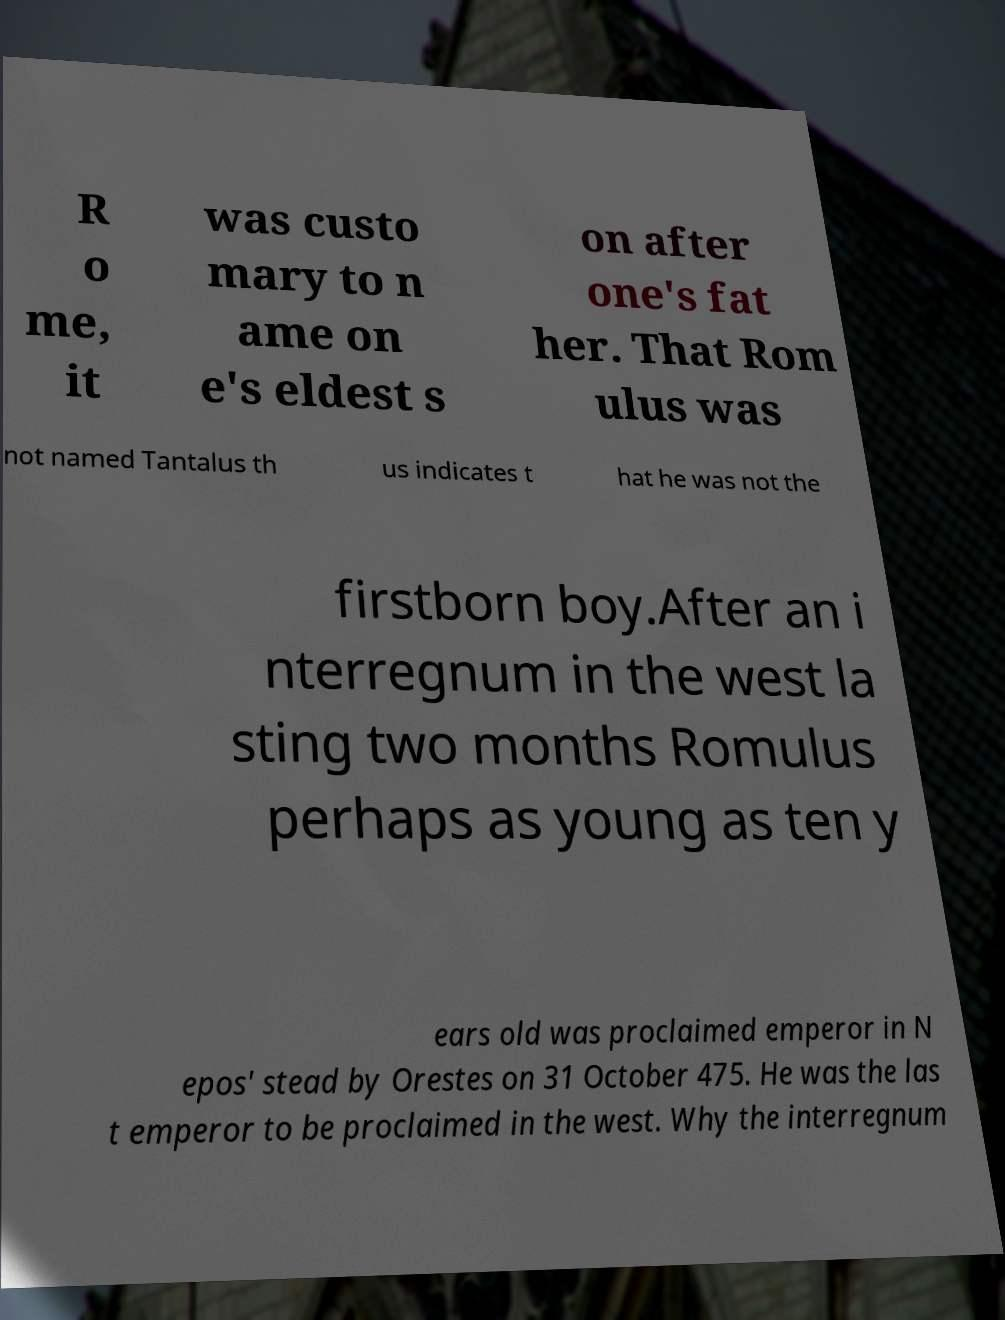Could you assist in decoding the text presented in this image and type it out clearly? R o me, it was custo mary to n ame on e's eldest s on after one's fat her. That Rom ulus was not named Tantalus th us indicates t hat he was not the firstborn boy.After an i nterregnum in the west la sting two months Romulus perhaps as young as ten y ears old was proclaimed emperor in N epos' stead by Orestes on 31 October 475. He was the las t emperor to be proclaimed in the west. Why the interregnum 